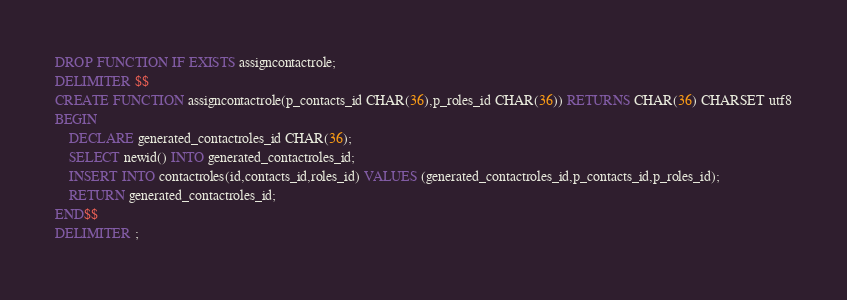<code> <loc_0><loc_0><loc_500><loc_500><_SQL_>DROP FUNCTION IF EXISTS assigncontactrole;
DELIMITER $$
CREATE FUNCTION assigncontactrole(p_contacts_id CHAR(36),p_roles_id CHAR(36)) RETURNS CHAR(36) CHARSET utf8
BEGIN
	DECLARE generated_contactroles_id CHAR(36);
	SELECT newid() INTO generated_contactroles_id;
	INSERT INTO contactroles(id,contacts_id,roles_id) VALUES (generated_contactroles_id,p_contacts_id,p_roles_id);
	RETURN generated_contactroles_id;
END$$
DELIMITER ;
</code> 